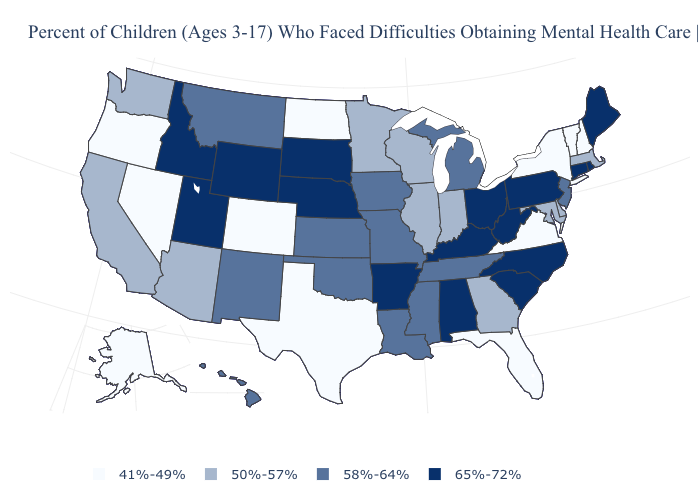What is the value of Nevada?
Concise answer only. 41%-49%. What is the value of New Jersey?
Keep it brief. 58%-64%. Which states have the lowest value in the USA?
Answer briefly. Alaska, Colorado, Florida, Nevada, New Hampshire, New York, North Dakota, Oregon, Texas, Vermont, Virginia. Does New York have the lowest value in the USA?
Be succinct. Yes. Name the states that have a value in the range 41%-49%?
Short answer required. Alaska, Colorado, Florida, Nevada, New Hampshire, New York, North Dakota, Oregon, Texas, Vermont, Virginia. What is the value of Montana?
Be succinct. 58%-64%. Name the states that have a value in the range 58%-64%?
Write a very short answer. Hawaii, Iowa, Kansas, Louisiana, Michigan, Mississippi, Missouri, Montana, New Jersey, New Mexico, Oklahoma, Tennessee. What is the value of North Dakota?
Write a very short answer. 41%-49%. Name the states that have a value in the range 41%-49%?
Concise answer only. Alaska, Colorado, Florida, Nevada, New Hampshire, New York, North Dakota, Oregon, Texas, Vermont, Virginia. What is the value of North Dakota?
Be succinct. 41%-49%. Among the states that border Florida , which have the highest value?
Write a very short answer. Alabama. Name the states that have a value in the range 65%-72%?
Quick response, please. Alabama, Arkansas, Connecticut, Idaho, Kentucky, Maine, Nebraska, North Carolina, Ohio, Pennsylvania, Rhode Island, South Carolina, South Dakota, Utah, West Virginia, Wyoming. Name the states that have a value in the range 65%-72%?
Be succinct. Alabama, Arkansas, Connecticut, Idaho, Kentucky, Maine, Nebraska, North Carolina, Ohio, Pennsylvania, Rhode Island, South Carolina, South Dakota, Utah, West Virginia, Wyoming. Among the states that border Florida , which have the lowest value?
Answer briefly. Georgia. What is the value of South Dakota?
Keep it brief. 65%-72%. 